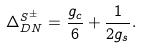Convert formula to latex. <formula><loc_0><loc_0><loc_500><loc_500>\Delta ^ { S ^ { \pm } } _ { D N } = \frac { g _ { c } } { 6 } + \frac { 1 } { 2 g _ { s } } .</formula> 